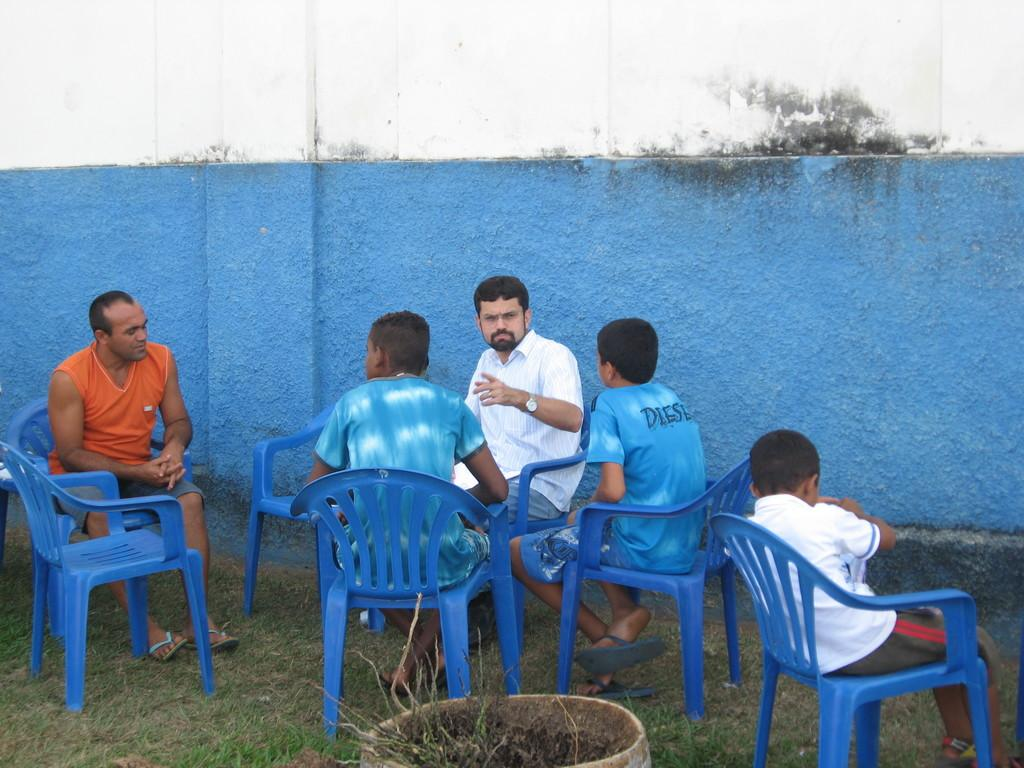What are the people sitting on in the image? The people are sitting on blue chairs in the image. How many men and boys are present among the people? There are two men and three boys among the people. Where are the chairs located? The chairs are located on grass patches. What color is the wall beside them? The wall beside them is painted blue. What type of news can be heard coming from the map in the image? There is no map present in the image, so it's not possible to determine what news might be heard. 